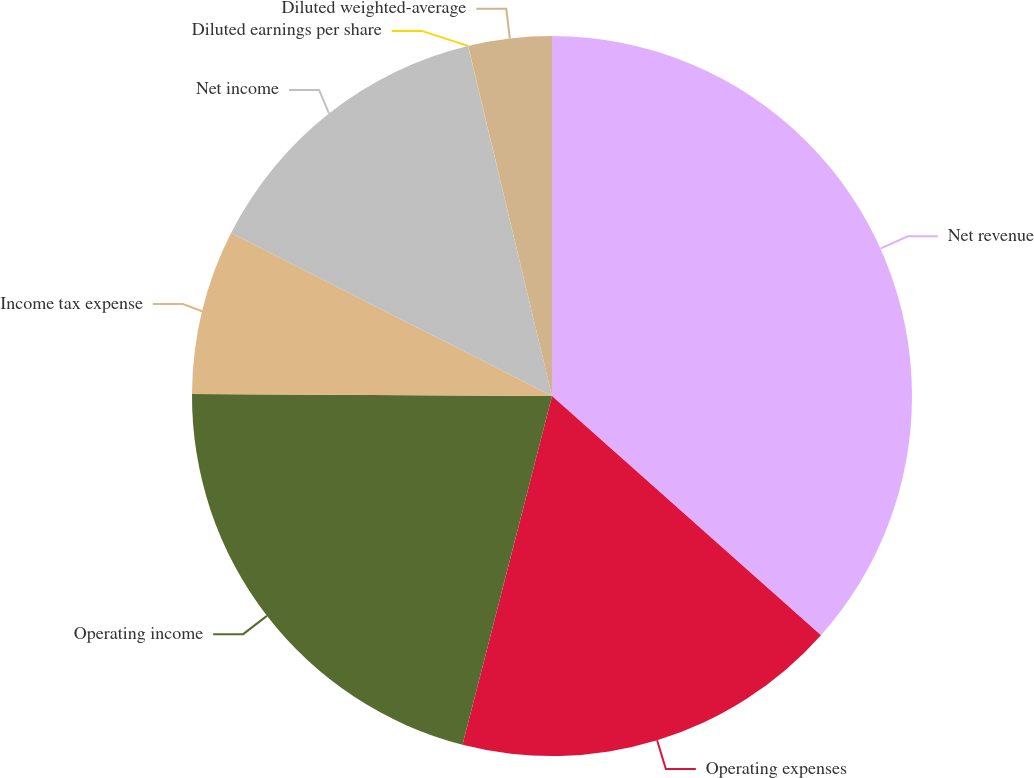Convert chart. <chart><loc_0><loc_0><loc_500><loc_500><pie_chart><fcel>Net revenue<fcel>Operating expenses<fcel>Operating income<fcel>Income tax expense<fcel>Net income<fcel>Diluted earnings per share<fcel>Diluted weighted-average<nl><fcel>36.57%<fcel>17.43%<fcel>21.09%<fcel>7.39%<fcel>13.77%<fcel>0.01%<fcel>3.74%<nl></chart> 